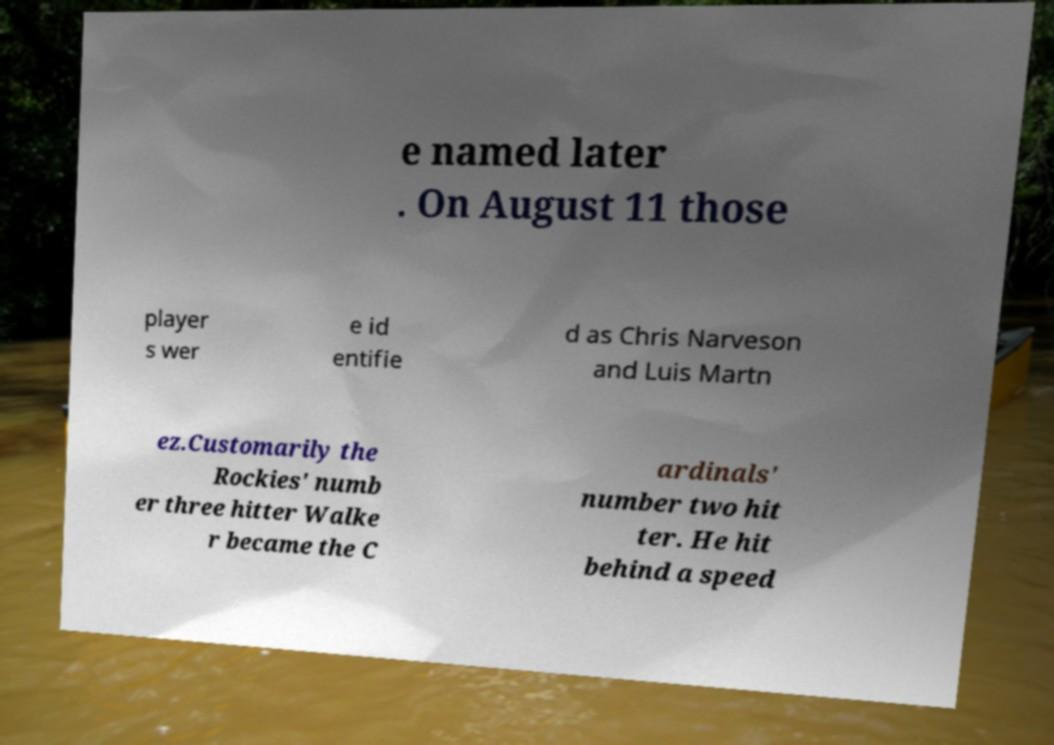For documentation purposes, I need the text within this image transcribed. Could you provide that? e named later . On August 11 those player s wer e id entifie d as Chris Narveson and Luis Martn ez.Customarily the Rockies' numb er three hitter Walke r became the C ardinals' number two hit ter. He hit behind a speed 